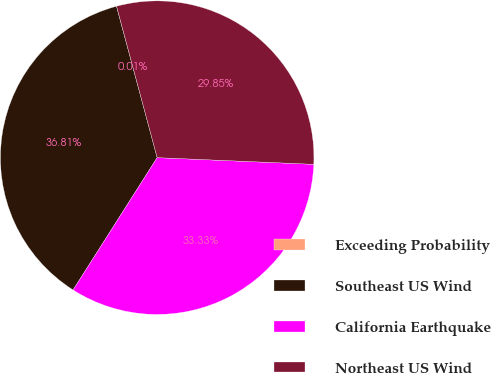Convert chart to OTSL. <chart><loc_0><loc_0><loc_500><loc_500><pie_chart><fcel>Exceeding Probability<fcel>Southeast US Wind<fcel>California Earthquake<fcel>Northeast US Wind<nl><fcel>0.01%<fcel>36.81%<fcel>33.33%<fcel>29.85%<nl></chart> 